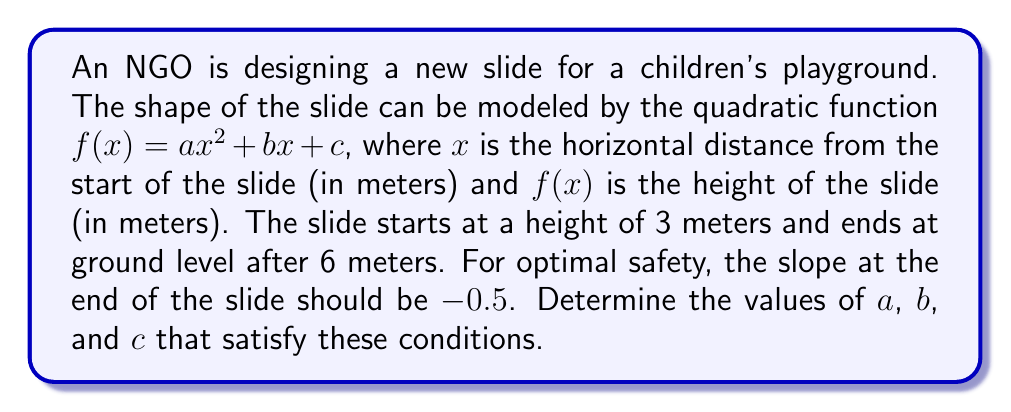Can you solve this math problem? 1) We know that the slide starts at $x = 0$ and $f(0) = 3$, so:
   $f(0) = a(0)^2 + b(0) + c = c = 3$

2) The slide ends at ground level when $x = 6$, so:
   $f(6) = a(6)^2 + b(6) + c = 0$
   $36a + 6b + 3 = 0$ ... (Equation 1)

3) The slope at the end of the slide is given by the derivative $f'(x)$ when $x = 6$:
   $f'(x) = 2ax + b$
   $f'(6) = 12a + b = -0.5$ ... (Equation 2)

4) From Equation 2:
   $b = -0.5 - 12a$ ... (Equation 3)

5) Substitute Equation 3 into Equation 1:
   $36a + 6(-0.5 - 12a) + 3 = 0$
   $36a - 3 - 72a + 3 = 0$
   $-36a = 0$
   $a = 0$

6) Substitute $a = 0$ into Equation 3:
   $b = -0.5 - 12(0) = -0.5$

7) We already know that $c = 3$ from step 1.

Therefore, $a = 0$, $b = -0.5$, and $c = 3$.
Answer: $a = 0$, $b = -0.5$, $c = 3$ 